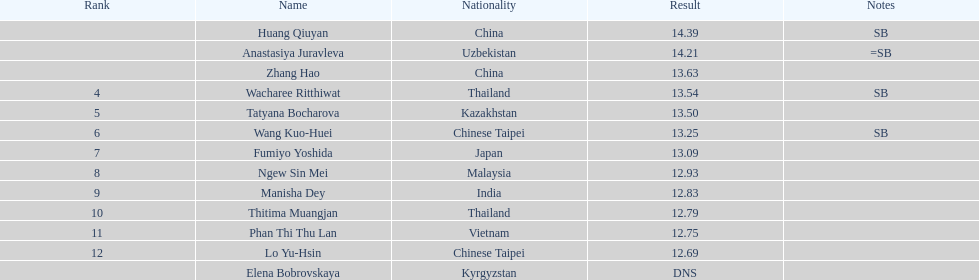Would you mind parsing the complete table? {'header': ['Rank', 'Name', 'Nationality', 'Result', 'Notes'], 'rows': [['', 'Huang Qiuyan', 'China', '14.39', 'SB'], ['', 'Anastasiya Juravleva', 'Uzbekistan', '14.21', '=SB'], ['', 'Zhang Hao', 'China', '13.63', ''], ['4', 'Wacharee Ritthiwat', 'Thailand', '13.54', 'SB'], ['5', 'Tatyana Bocharova', 'Kazakhstan', '13.50', ''], ['6', 'Wang Kuo-Huei', 'Chinese Taipei', '13.25', 'SB'], ['7', 'Fumiyo Yoshida', 'Japan', '13.09', ''], ['8', 'Ngew Sin Mei', 'Malaysia', '12.93', ''], ['9', 'Manisha Dey', 'India', '12.83', ''], ['10', 'Thitima Muangjan', 'Thailand', '12.79', ''], ['11', 'Phan Thi Thu Lan', 'Vietnam', '12.75', ''], ['12', 'Lo Yu-Hsin', 'Chinese Taipei', '12.69', ''], ['', 'Elena Bobrovskaya', 'Kyrgyzstan', 'DNS', '']]} 00 points? 6. 